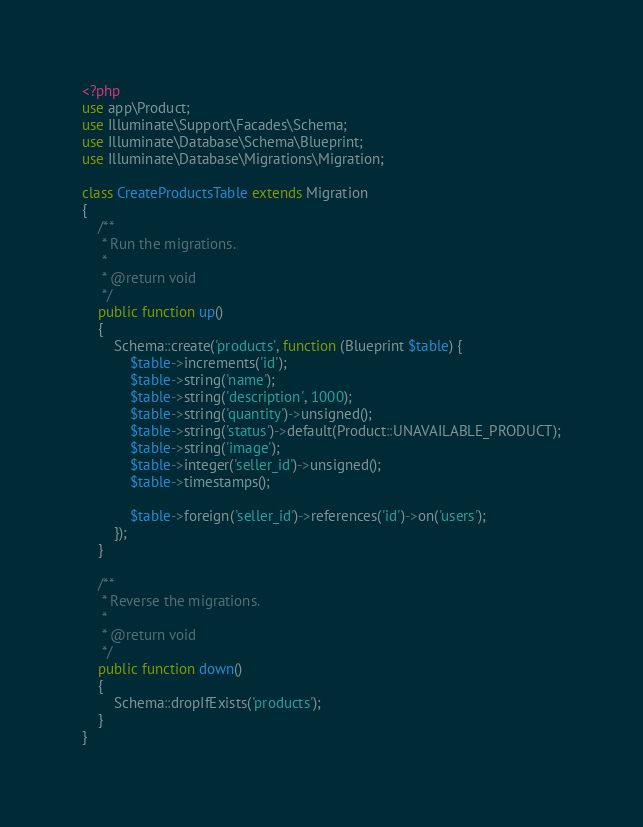<code> <loc_0><loc_0><loc_500><loc_500><_PHP_><?php
use app\Product;
use Illuminate\Support\Facades\Schema;
use Illuminate\Database\Schema\Blueprint;
use Illuminate\Database\Migrations\Migration;

class CreateProductsTable extends Migration
{
    /**
     * Run the migrations.
     *
     * @return void
     */
    public function up()
    {
        Schema::create('products', function (Blueprint $table) {
            $table->increments('id');
            $table->string('name');
            $table->string('description', 1000);
            $table->string('quantity')->unsigned();
            $table->string('status')->default(Product::UNAVAILABLE_PRODUCT);
            $table->string('image');
            $table->integer('seller_id')->unsigned();
            $table->timestamps();

            $table->foreign('seller_id')->references('id')->on('users');
        });
    }

    /**
     * Reverse the migrations.
     *
     * @return void
     */
    public function down()
    {
        Schema::dropIfExists('products');
    }
}
</code> 